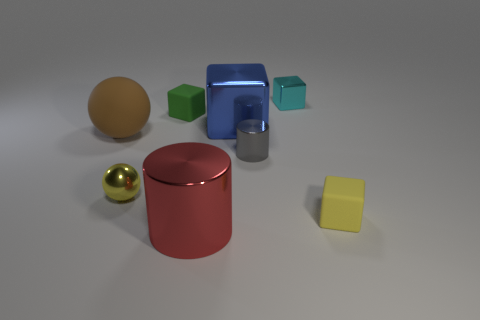Are there fewer purple things than gray cylinders?
Keep it short and to the point. Yes. The small matte object that is on the right side of the cylinder behind the tiny rubber object in front of the small metal cylinder is what shape?
Offer a very short reply. Cube. The matte thing that is the same color as the small ball is what shape?
Make the answer very short. Cube. Are any yellow metal spheres visible?
Make the answer very short. Yes. There is a green block; is its size the same as the metal cube that is in front of the tiny cyan shiny block?
Offer a very short reply. No. Are there any cyan blocks that are to the left of the small rubber object that is in front of the brown ball?
Keep it short and to the point. Yes. What material is the tiny thing that is on the left side of the big metallic cube and in front of the big brown matte object?
Offer a very short reply. Metal. What color is the tiny matte cube behind the matte thing that is right of the rubber block that is behind the large blue cube?
Offer a very short reply. Green. The matte thing that is the same size as the blue metallic thing is what color?
Your response must be concise. Brown. There is a large rubber sphere; is its color the same as the tiny matte thing that is behind the yellow shiny ball?
Give a very brief answer. No. 